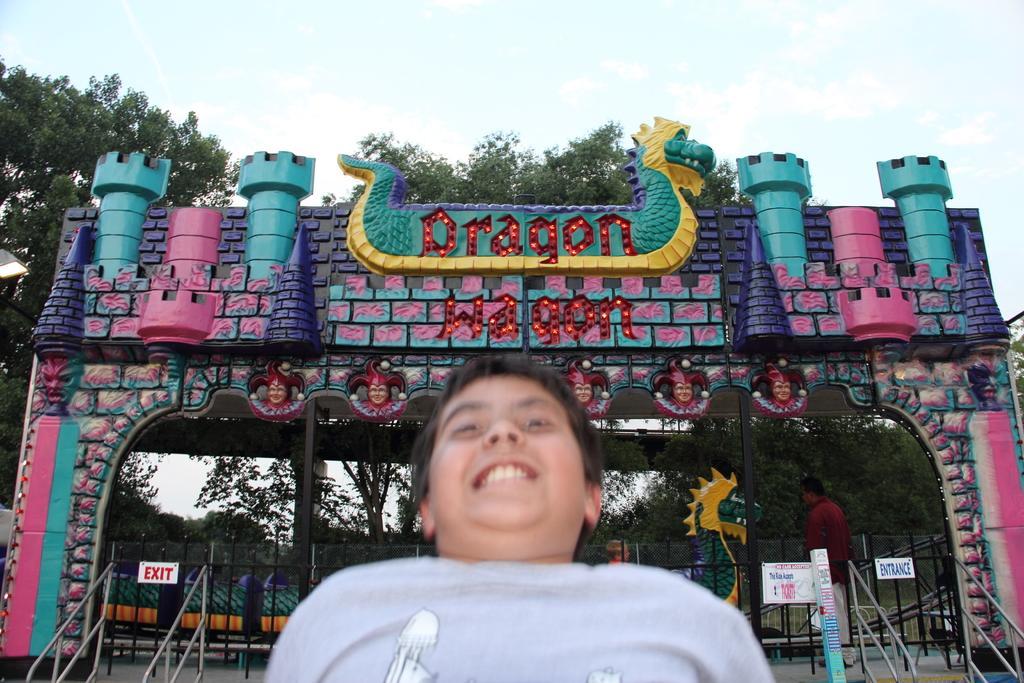How would you summarize this image in a sentence or two? In the image there is a boy and behind the boy there is an entrance gate of some event, it is very decorative and behind that entrance gate there are many trees. 